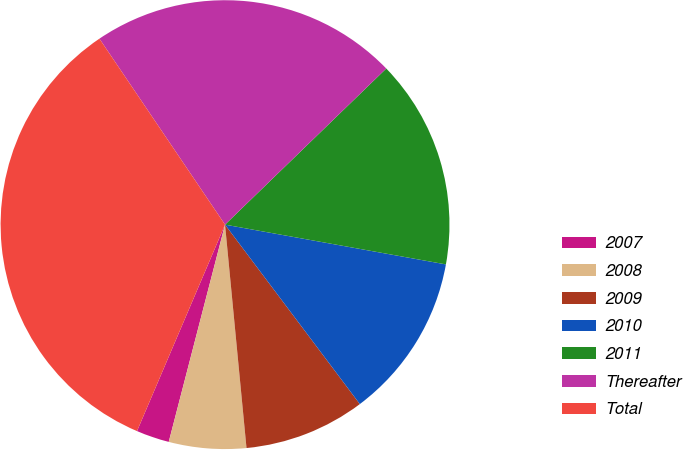Convert chart. <chart><loc_0><loc_0><loc_500><loc_500><pie_chart><fcel>2007<fcel>2008<fcel>2009<fcel>2010<fcel>2011<fcel>Thereafter<fcel>Total<nl><fcel>2.38%<fcel>5.56%<fcel>8.73%<fcel>11.91%<fcel>15.08%<fcel>22.21%<fcel>34.13%<nl></chart> 